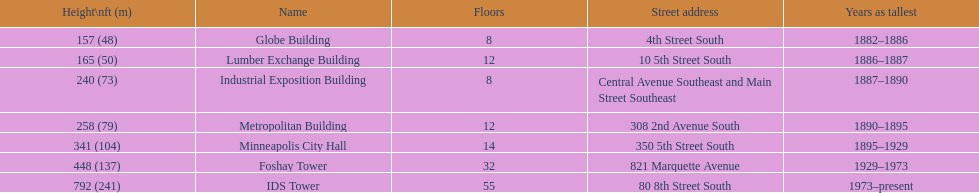How many floors does the foshay tower have? 32. 